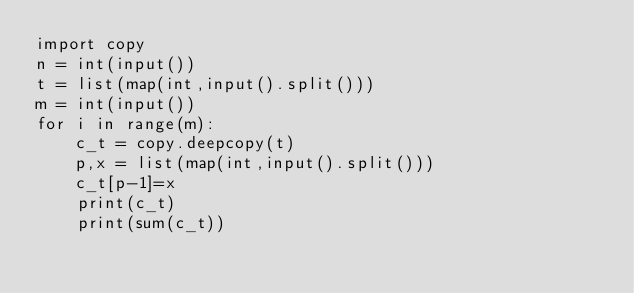<code> <loc_0><loc_0><loc_500><loc_500><_Python_>import copy
n = int(input())
t = list(map(int,input().split()))
m = int(input())
for i in range(m):
    c_t = copy.deepcopy(t)
    p,x = list(map(int,input().split()))
    c_t[p-1]=x
    print(c_t)
    print(sum(c_t))</code> 